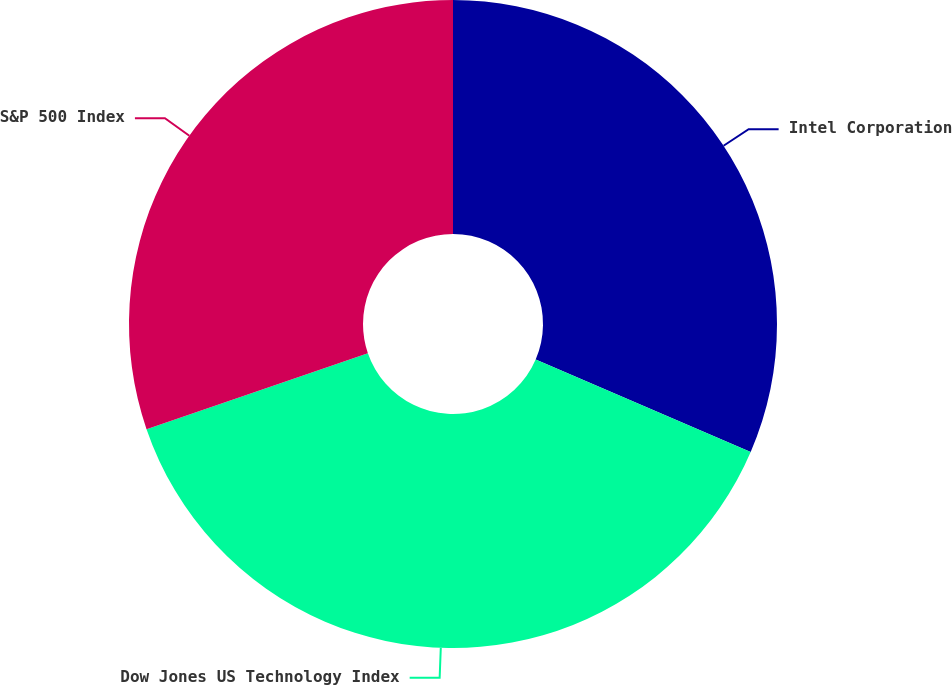<chart> <loc_0><loc_0><loc_500><loc_500><pie_chart><fcel>Intel Corporation<fcel>Dow Jones US Technology Index<fcel>S&P 500 Index<nl><fcel>31.46%<fcel>38.28%<fcel>30.26%<nl></chart> 